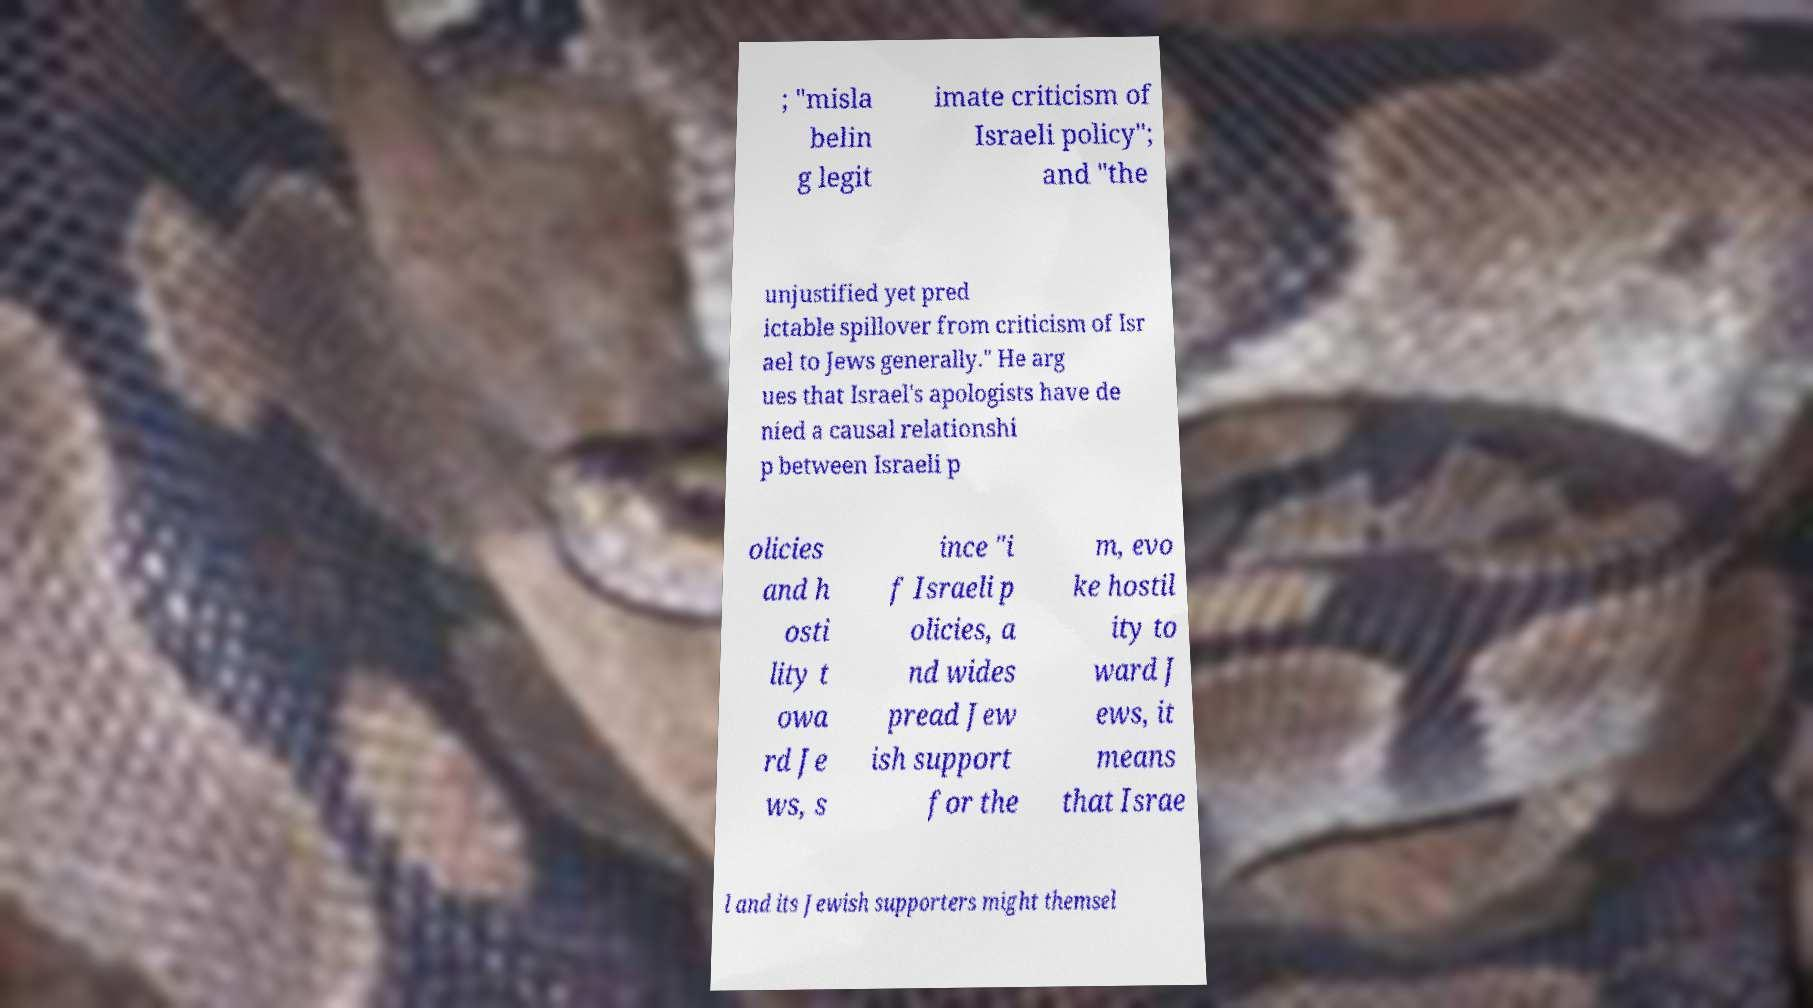Could you assist in decoding the text presented in this image and type it out clearly? ; "misla belin g legit imate criticism of Israeli policy"; and "the unjustified yet pred ictable spillover from criticism of Isr ael to Jews generally." He arg ues that Israel's apologists have de nied a causal relationshi p between Israeli p olicies and h osti lity t owa rd Je ws, s ince "i f Israeli p olicies, a nd wides pread Jew ish support for the m, evo ke hostil ity to ward J ews, it means that Israe l and its Jewish supporters might themsel 